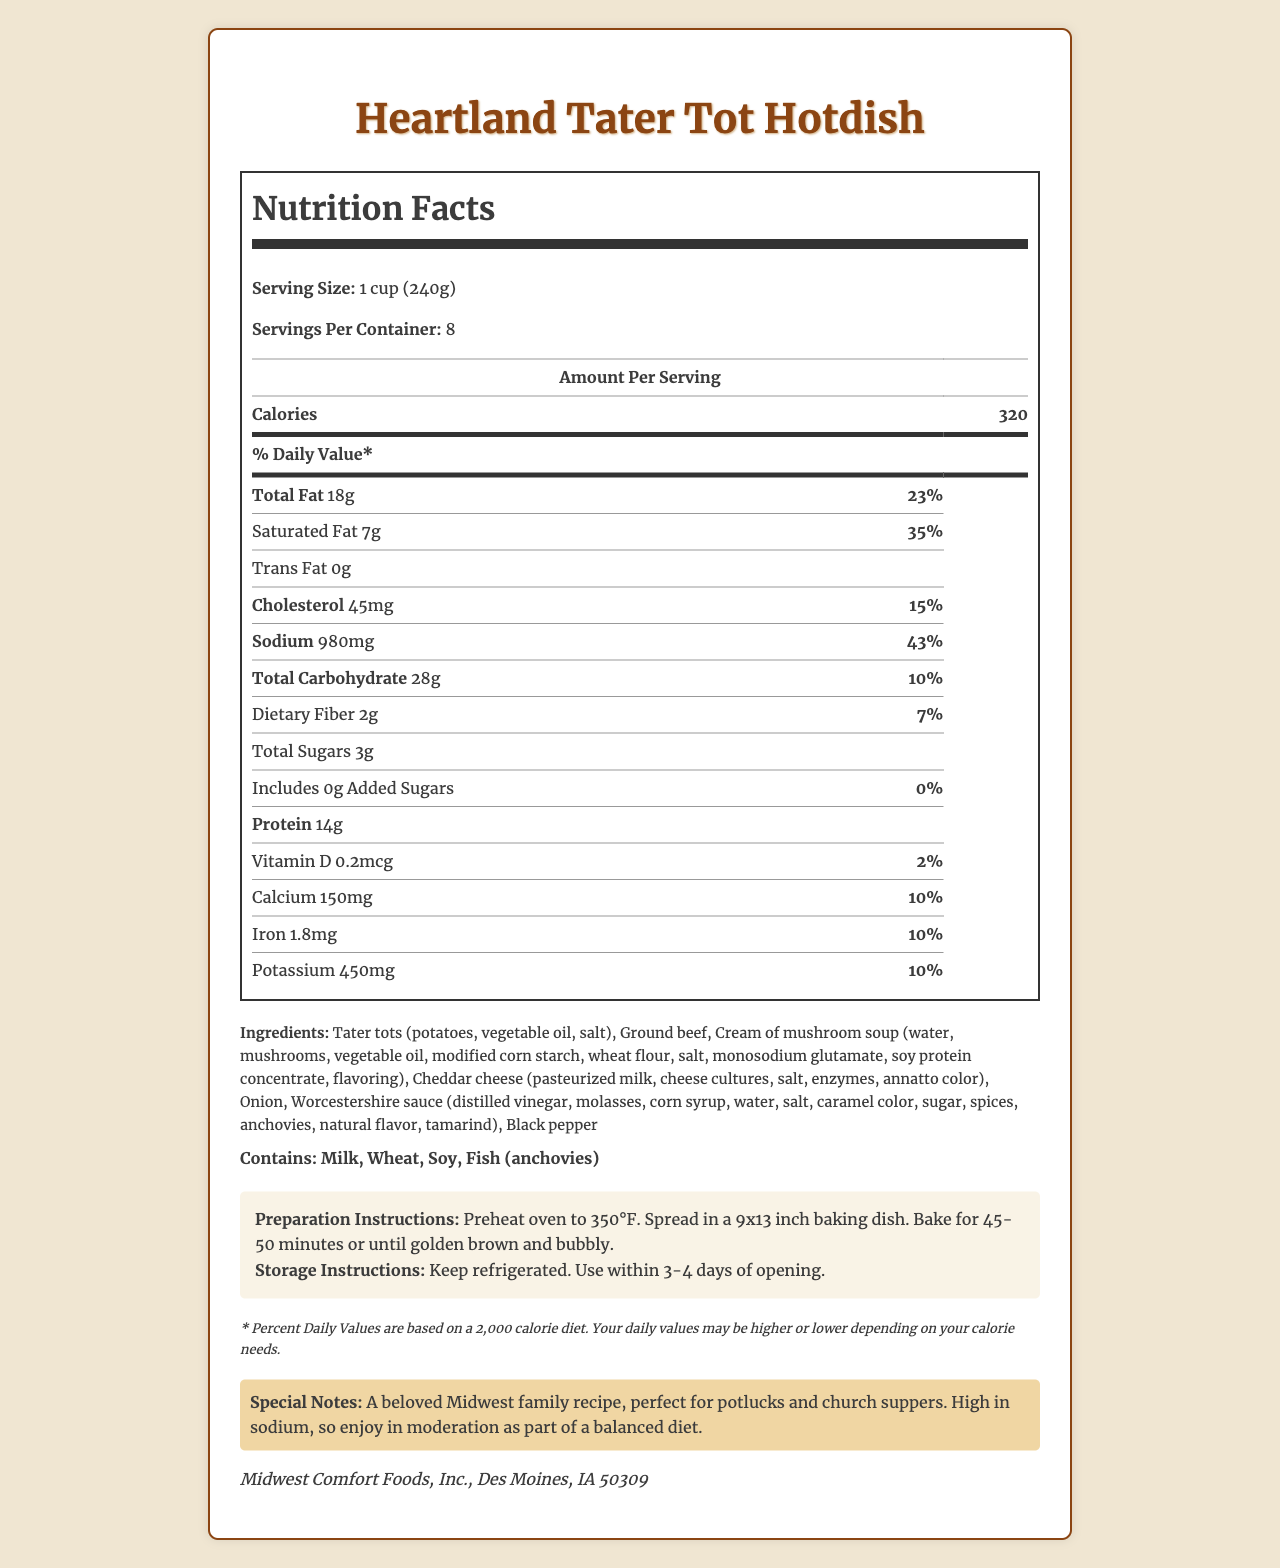what is the serving size of the Heartland Tater Tot Hotdish? The serving size is clearly indicated in the document as "1 cup (240g)".
Answer: 1 cup (240g) how many servings are there in one container? The document states that there are 8 servings per container.
Answer: 8 how many calories are in one serving? Under the "Amount Per Serving" section, it is listed that one serving contains 320 calories.
Answer: 320 how much sodium does each serving contain? The sodium content in one serving is given as 980mg.
Answer: 980mg what percentage of the daily value is the saturated fat? The document indicates that the saturated fat content provides 35% of the daily value.
Answer: 35% which ingredient contributes to the cholesterol content? Both ground beef and cheddar cheese are likely contributors to the cholesterol content, given their usual nutritional profiles.
Answer: Ground beef, Cheddar cheese how is this dish best described in terms of dietary health? A. Low sodium B. High protein C. High sodium D. Low calorie The special notes mention that the dish is high in sodium and should be enjoyed in moderation.
Answer: C. High sodium which major allergens are present in the Heartland Tater Tot Hotdish? A. Dairy, Wheat, Soy B. Tree nuts, Soy, Peanuts C. Wheat, Eggs, Shellfish The allergens listed are milk (dairy), wheat, soy, and fish (anchovies).
Answer: A. Dairy, Wheat, Soy is there any added sugar in this dish? The document shows that the added sugars amount is 0g, with a daily value of 0%.
Answer: No does this dish contain fish? The ingredient list includes Worcestershire sauce, which contains anchovies.
Answer: Yes does the product include any instructions for preparation? The preparation instructions are provided, mentioning preheating the oven to 350°F, spreading in a baking dish, and baking for 45-50 minutes.
Answer: Yes what are the main ingredients of this dish? The ingredients are listed explicitly in the document.
Answer: Tater tots, ground beef, cream of mushroom soup, cheddar cheese, onion, Worcestershire sauce, black pepper summarize the main nutritional characteristics of the Heartland Tater Tot Hotdish. This summary encapsulates the key nutritional aspects, preparation method, and dietary considerations mentioned in the document.
Answer: The Heartland Tater Tot Hotdish is a high-calorie, high-sodium Midwest casserole dish with notable fat and protein content. It includes common allergens such as milk, wheat, soy, and fish. Preparation involves baking, and it should be enjoyed in moderation due to its high sodium content. how long should the product be used after opening? The document specifies that the product should be used within 3-4 days after opening.
Answer: Use within 3-4 days of opening does the document mention any specific vitamin content? The document lists Vitamin D as being present at 0.2 mcg per serving, which is 2% of the daily value.
Answer: Yes, Vitamin D how many grams of protein does one serving contain? The amount of protein per serving is given as 14 grams.
Answer: 14g does the product have a low or high potassium content compared to daily value? The potassium content per serving is 450mg, which is 10% of the daily value.
Answer: 10% Daily Value where is the manufacturer of the Heartland Tater Tot Hotdish located? The manufacturer is Midwest Comfort Foods, Inc., located in Des Moines, IA 50309.
Answer: Des Moines, IA 50309 what is the main purpose of the disclaimer in the document? The disclaimer provides context for the daily values and how they relate to different dietary requirements.
Answer: To indicate that daily values are based on a 2,000 calorie diet and may vary based on individual calorie needs. is there enough information to determine the exact number of calories in the entire container? With 320 calories per serving and 8 servings per container, the total calories in the container would be 320 calories x 8 servings = 2560 calories.
Answer: Yes 